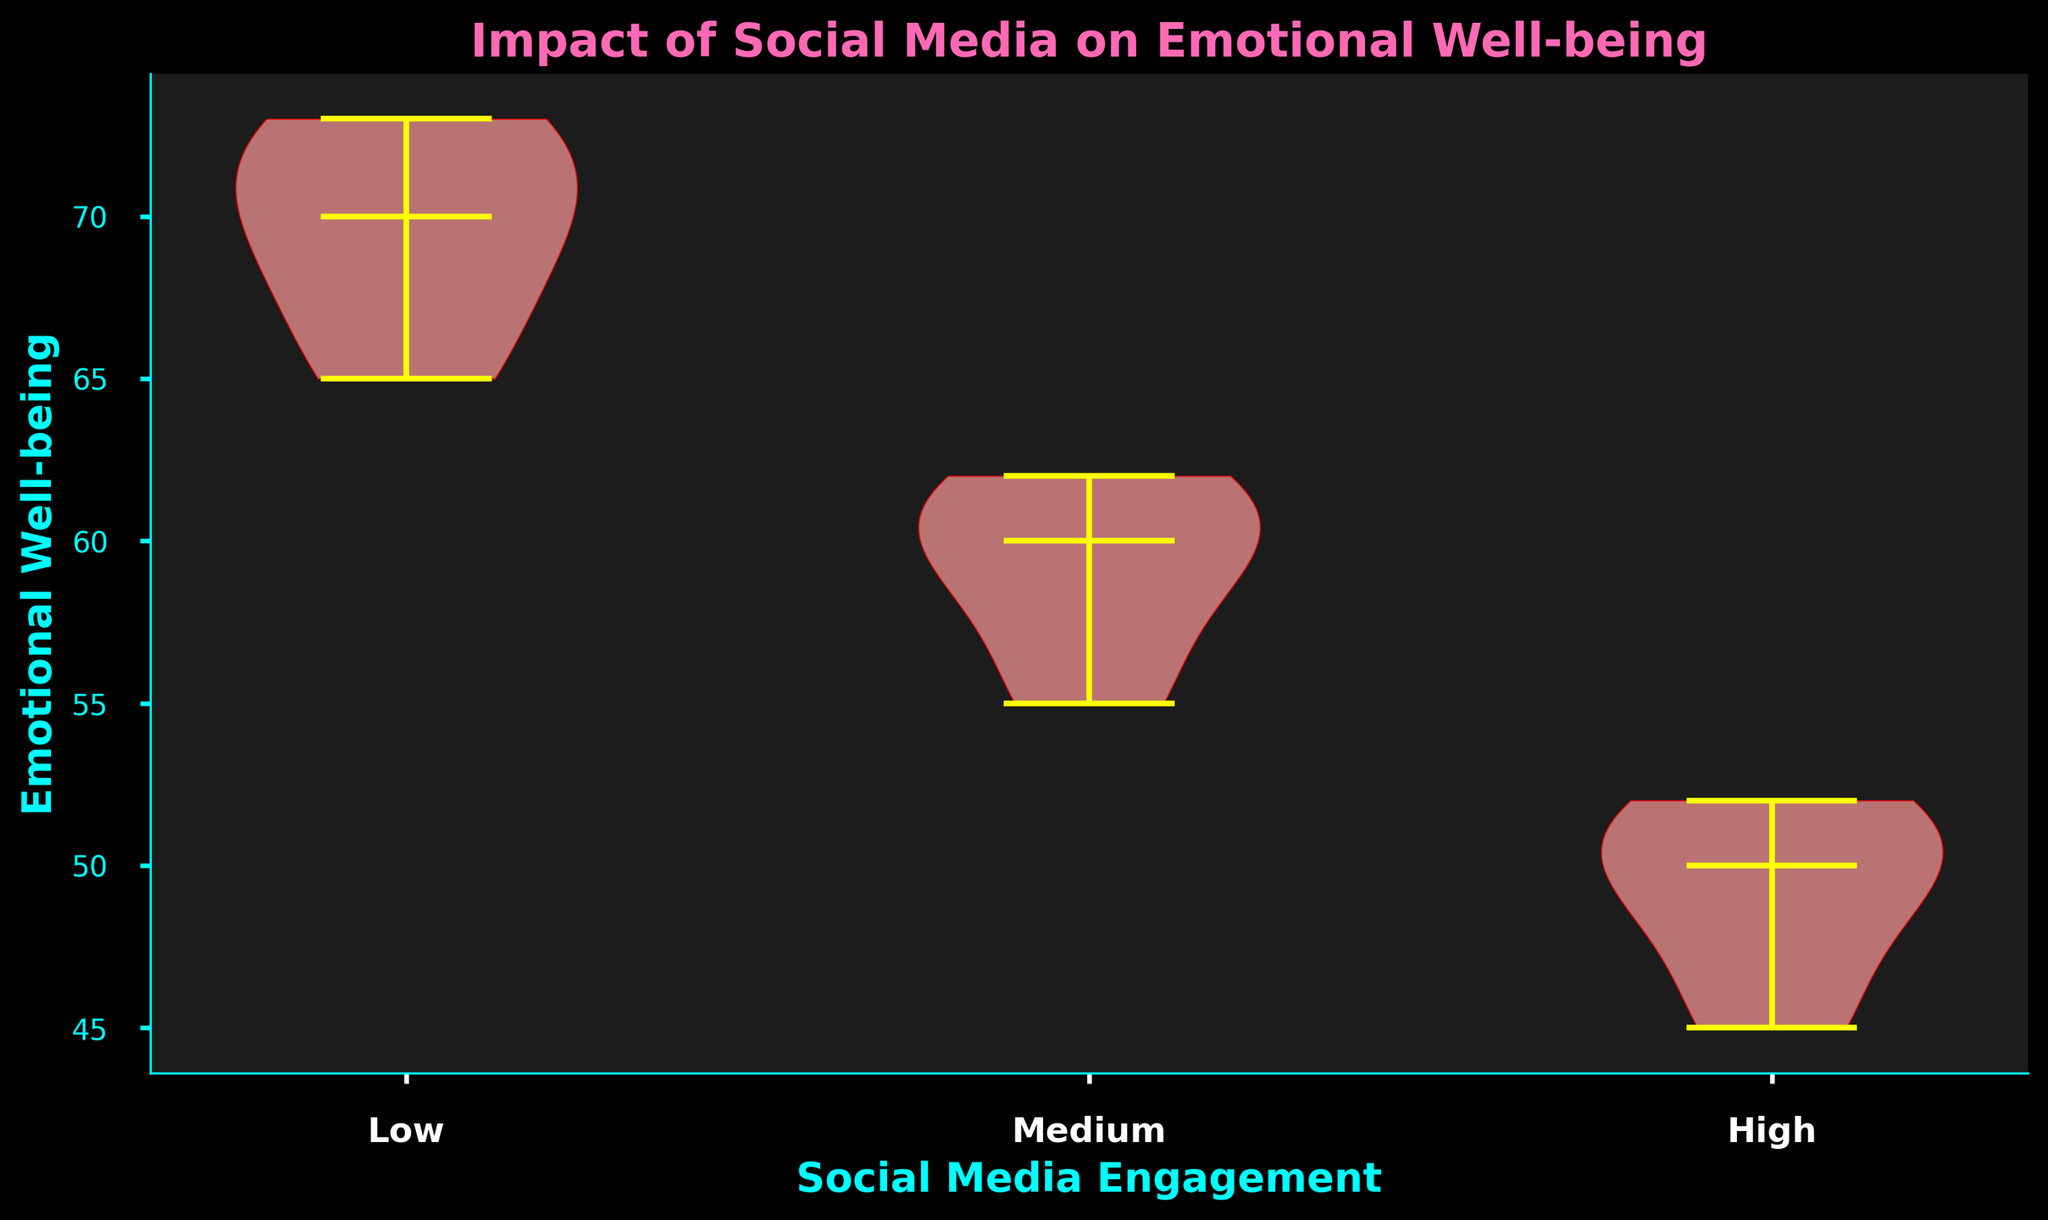What's the title of the figure? The title is located at the top of the figure, summarizing the plot's overall content.
Answer: Impact of Social Media on Emotional Well-being What does the y-axis represent? The y-axis label is placed vertically along the left side of the chart, indicating what is being measured.
Answer: Emotional Well-being Which social media engagement level has the highest median emotional well-being? The median is shown as a horizontal line within each violin plot. The highest median line corresponds to the "Low" social media engagement group.
Answer: Low How does emotional well-being compare between the high and low social media engagement groups? By comparing the median lines and observing the spread of the data in each violin plot, it is clear that the "Low" social media engagement group has a higher and less varied emotional well-being, while the "High" group has a lower and more concentrated one.
Answer: The low group has higher emotional well-being and is less varied Which social media engagement group shows the smallest range in emotional well-being? The range can be observed by the vertical span that the violin plot covers. The "High" engagement group's plot appears to span the smallest range.
Answer: High What can you infer about emotional well-being for the "Medium" social media engagement group? The "Medium" engagement group's violin plot has a distributed data spread, with the median line lower than the "Low" group but higher than the "High" group, suggesting moderate emotional well-being levels.
Answer: Moderate well-being How are the colors utilized in the figure? The bodies of the violin plots are colored in light pink with red edges, and the median lines and other violin plot components are highlighted in yellow. The background is dark, accentuating these colors.
Answer: Pink with red edges and yellow median lines What group has the most varied emotional well-being? The variation in emotional well-being can be inferred from the width and spread of the violin plots. The "Low" engagement group's plot appears to be the most varied, spreading across a wider range.
Answer: Low If emotional well-being is assumed to be optimal at higher values, how does increased social media engagement impact this metric? Comparing the median lines across the three categories, it is apparent that as social media engagement increases from low to high, the median emotional well-being decreases, indicating a possible negative impact.
Answer: Decreases 